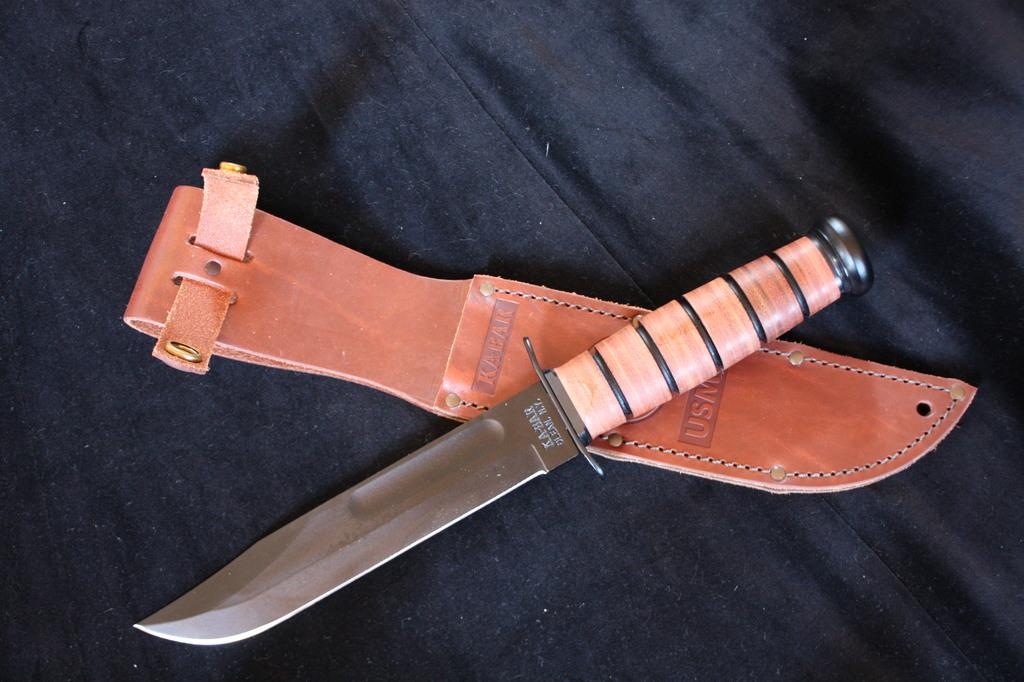What object is present in the image that can be used for cutting? There is a knife in the image. Does the knife have any additional features? Yes, the knife has a cover. Where is the knife and its cover placed in the image? The knife and its cover are placed on a black cloth. What type of bean is visible in the image? There is no bean present in the image. How does the knife roll across the black cloth in the image? The knife does not roll across the black cloth in the image; it is stationary with its cover on. 